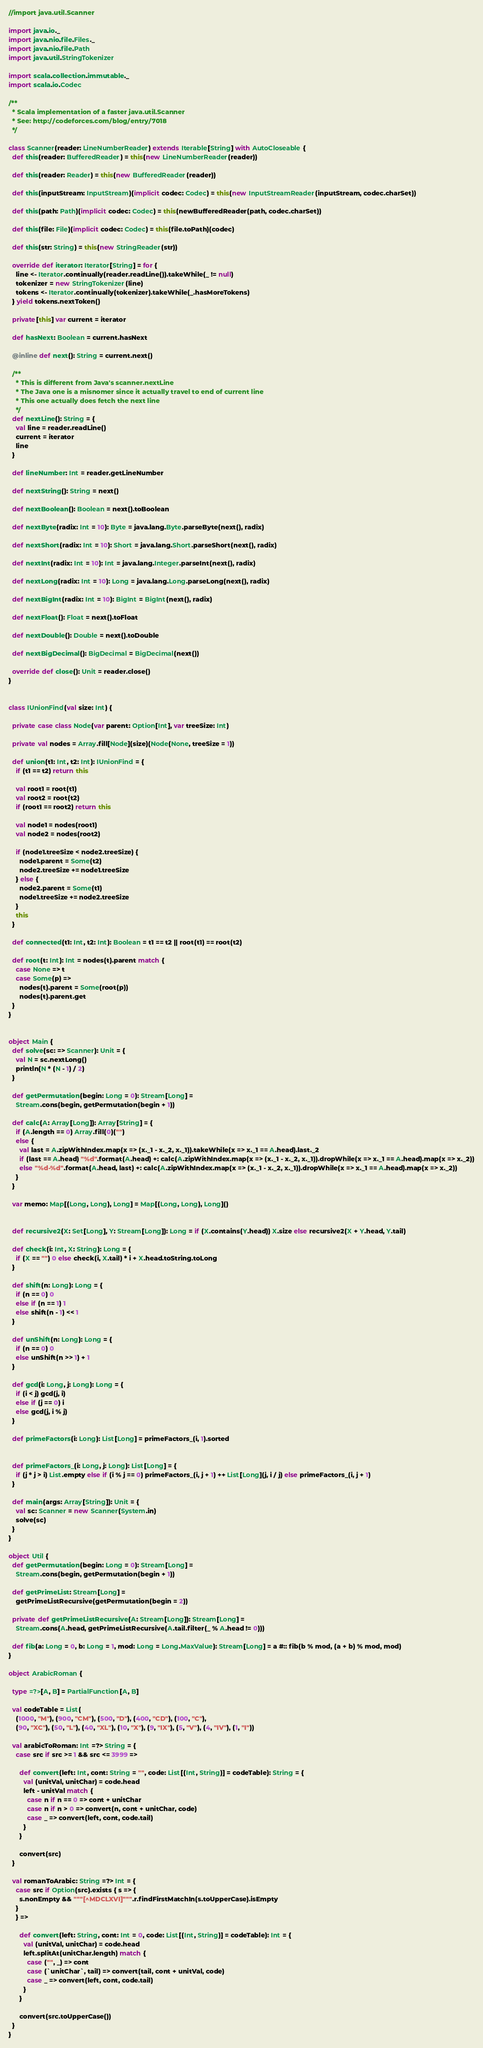<code> <loc_0><loc_0><loc_500><loc_500><_Scala_>//import java.util.Scanner

import java.io._
import java.nio.file.Files._
import java.nio.file.Path
import java.util.StringTokenizer

import scala.collection.immutable._
import scala.io.Codec

/**
  * Scala implementation of a faster java.util.Scanner
  * See: http://codeforces.com/blog/entry/7018
  */

class Scanner(reader: LineNumberReader) extends Iterable[String] with AutoCloseable {
  def this(reader: BufferedReader) = this(new LineNumberReader(reader))

  def this(reader: Reader) = this(new BufferedReader(reader))

  def this(inputStream: InputStream)(implicit codec: Codec) = this(new InputStreamReader(inputStream, codec.charSet))

  def this(path: Path)(implicit codec: Codec) = this(newBufferedReader(path, codec.charSet))

  def this(file: File)(implicit codec: Codec) = this(file.toPath)(codec)

  def this(str: String) = this(new StringReader(str))

  override def iterator: Iterator[String] = for {
    line <- Iterator.continually(reader.readLine()).takeWhile(_ != null)
    tokenizer = new StringTokenizer(line)
    tokens <- Iterator.continually(tokenizer).takeWhile(_.hasMoreTokens)
  } yield tokens.nextToken()

  private[this] var current = iterator

  def hasNext: Boolean = current.hasNext

  @inline def next(): String = current.next()

  /**
    * This is different from Java's scanner.nextLine
    * The Java one is a misnomer since it actually travel to end of current line
    * This one actually does fetch the next line
    */
  def nextLine(): String = {
    val line = reader.readLine()
    current = iterator
    line
  }

  def lineNumber: Int = reader.getLineNumber

  def nextString(): String = next()

  def nextBoolean(): Boolean = next().toBoolean

  def nextByte(radix: Int = 10): Byte = java.lang.Byte.parseByte(next(), radix)

  def nextShort(radix: Int = 10): Short = java.lang.Short.parseShort(next(), radix)

  def nextInt(radix: Int = 10): Int = java.lang.Integer.parseInt(next(), radix)

  def nextLong(radix: Int = 10): Long = java.lang.Long.parseLong(next(), radix)

  def nextBigInt(radix: Int = 10): BigInt = BigInt(next(), radix)

  def nextFloat(): Float = next().toFloat

  def nextDouble(): Double = next().toDouble

  def nextBigDecimal(): BigDecimal = BigDecimal(next())

  override def close(): Unit = reader.close()
}


class IUnionFind(val size: Int) {

  private case class Node(var parent: Option[Int], var treeSize: Int)

  private val nodes = Array.fill[Node](size)(Node(None, treeSize = 1))

  def union(t1: Int, t2: Int): IUnionFind = {
    if (t1 == t2) return this

    val root1 = root(t1)
    val root2 = root(t2)
    if (root1 == root2) return this

    val node1 = nodes(root1)
    val node2 = nodes(root2)

    if (node1.treeSize < node2.treeSize) {
      node1.parent = Some(t2)
      node2.treeSize += node1.treeSize
    } else {
      node2.parent = Some(t1)
      node1.treeSize += node2.treeSize
    }
    this
  }

  def connected(t1: Int, t2: Int): Boolean = t1 == t2 || root(t1) == root(t2)

  def root(t: Int): Int = nodes(t).parent match {
    case None => t
    case Some(p) =>
      nodes(t).parent = Some(root(p))
      nodes(t).parent.get
  }
}


object Main {
  def solve(sc: => Scanner): Unit = {
    val N = sc.nextLong()
    println(N * (N - 1) / 2)
  }

  def getPermutation(begin: Long = 0): Stream[Long] =
    Stream.cons(begin, getPermutation(begin + 1))

  def calc(A: Array[Long]): Array[String] = {
    if (A.length == 0) Array.fill(0)("")
    else {
      val last = A.zipWithIndex.map(x => (x._1 - x._2, x._1)).takeWhile(x => x._1 == A.head).last._2
      if (last == A.head) "%d".format(A.head) +: calc(A.zipWithIndex.map(x => (x._1 - x._2, x._1)).dropWhile(x => x._1 == A.head).map(x => x._2))
      else "%d-%d".format(A.head, last) +: calc(A.zipWithIndex.map(x => (x._1 - x._2, x._1)).dropWhile(x => x._1 == A.head).map(x => x._2))
    }
  }

  var memo: Map[(Long, Long), Long] = Map[(Long, Long), Long]()


  def recursive2(X: Set[Long], Y: Stream[Long]): Long = if (X.contains(Y.head)) X.size else recursive2(X + Y.head, Y.tail)

  def check(i: Int, X: String): Long = {
    if (X == "") 0 else check(i, X.tail) * i + X.head.toString.toLong
  }

  def shift(n: Long): Long = {
    if (n == 0) 0
    else if (n == 1) 1
    else shift(n - 1) << 1
  }

  def unShift(n: Long): Long = {
    if (n == 0) 0
    else unShift(n >> 1) + 1
  }

  def gcd(i: Long, j: Long): Long = {
    if (i < j) gcd(j, i)
    else if (j == 0) i
    else gcd(j, i % j)
  }

  def primeFactors(i: Long): List[Long] = primeFactors_(i, 1).sorted


  def primeFactors_(i: Long, j: Long): List[Long] = {
    if (j * j > i) List.empty else if (i % j == 0) primeFactors_(i, j + 1) ++ List[Long](j, i / j) else primeFactors_(i, j + 1)
  }

  def main(args: Array[String]): Unit = {
    val sc: Scanner = new Scanner(System.in)
    solve(sc)
  }
}

object Util {
  def getPermutation(begin: Long = 0): Stream[Long] =
    Stream.cons(begin, getPermutation(begin + 1))

  def getPrimeList: Stream[Long] =
    getPrimeListRecursive(getPermutation(begin = 2))

  private def getPrimeListRecursive(A: Stream[Long]): Stream[Long] =
    Stream.cons(A.head, getPrimeListRecursive(A.tail.filter(_ % A.head != 0)))

  def fib(a: Long = 0, b: Long = 1, mod: Long = Long.MaxValue): Stream[Long] = a #:: fib(b % mod, (a + b) % mod, mod)
}

object ArabicRoman {

  type =?>[A, B] = PartialFunction[A, B]

  val codeTable = List(
    (1000, "M"), (900, "CM"), (500, "D"), (400, "CD"), (100, "C"),
    (90, "XC"), (50, "L"), (40, "XL"), (10, "X"), (9, "IX"), (5, "V"), (4, "IV"), (1, "I"))

  val arabicToRoman: Int =?> String = {
    case src if src >= 1 && src <= 3999 =>

      def convert(left: Int, cont: String = "", code: List[(Int, String)] = codeTable): String = {
        val (unitVal, unitChar) = code.head
        left - unitVal match {
          case n if n == 0 => cont + unitChar
          case n if n > 0 => convert(n, cont + unitChar, code)
          case _ => convert(left, cont, code.tail)
        }
      }

      convert(src)
  }

  val romanToArabic: String =?> Int = {
    case src if Option(src).exists { s => {
      s.nonEmpty && """[^MDCLXVI]""".r.findFirstMatchIn(s.toUpperCase).isEmpty
    }
    } =>

      def convert(left: String, cont: Int = 0, code: List[(Int, String)] = codeTable): Int = {
        val (unitVal, unitChar) = code.head
        left.splitAt(unitChar.length) match {
          case ("", _) => cont
          case (`unitChar`, tail) => convert(tail, cont + unitVal, code)
          case _ => convert(left, cont, code.tail)
        }
      }

      convert(src.toUpperCase())
  }
}
</code> 